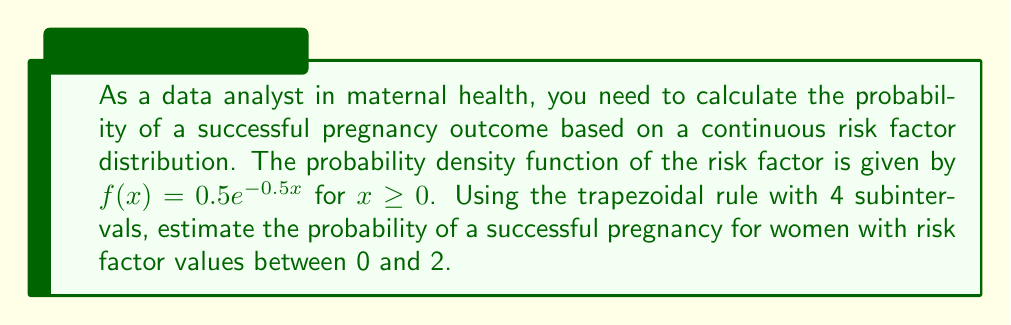What is the answer to this math problem? 1) The probability we need to calculate is given by the integral:

   $P = \int_0^2 f(x) dx = \int_0^2 0.5e^{-0.5x} dx$

2) We'll use the trapezoidal rule with 4 subintervals. The formula is:

   $\int_a^b f(x) dx \approx \frac{h}{2}[f(x_0) + 2f(x_1) + 2f(x_2) + 2f(x_3) + f(x_4)]$

   where $h = \frac{b-a}{n}$, $n$ is the number of subintervals, and $x_i = a + ih$

3) Calculate $h$:
   $h = \frac{2-0}{4} = 0.5$

4) Calculate the $x$ values:
   $x_0 = 0$
   $x_1 = 0.5$
   $x_2 = 1$
   $x_3 = 1.5$
   $x_4 = 2$

5) Calculate $f(x)$ for each $x$ value:
   $f(0) = 0.5e^{-0.5(0)} = 0.5$
   $f(0.5) = 0.5e^{-0.5(0.5)} \approx 0.3894$
   $f(1) = 0.5e^{-0.5(1)} \approx 0.3033$
   $f(1.5) = 0.5e^{-0.5(1.5)} \approx 0.2361$
   $f(2) = 0.5e^{-0.5(2)} \approx 0.1839$

6) Apply the trapezoidal rule:

   $P \approx \frac{0.5}{2}[0.5 + 2(0.3894) + 2(0.3033) + 2(0.2361) + 0.1839]$
   $= 0.25[0.5 + 0.7788 + 0.6066 + 0.4722 + 0.1839]$
   $= 0.25[2.5415]$
   $= 0.6354$

Therefore, the estimated probability of a successful pregnancy for women with risk factor values between 0 and 2 is approximately 0.6354 or 63.54%.
Answer: 0.6354 